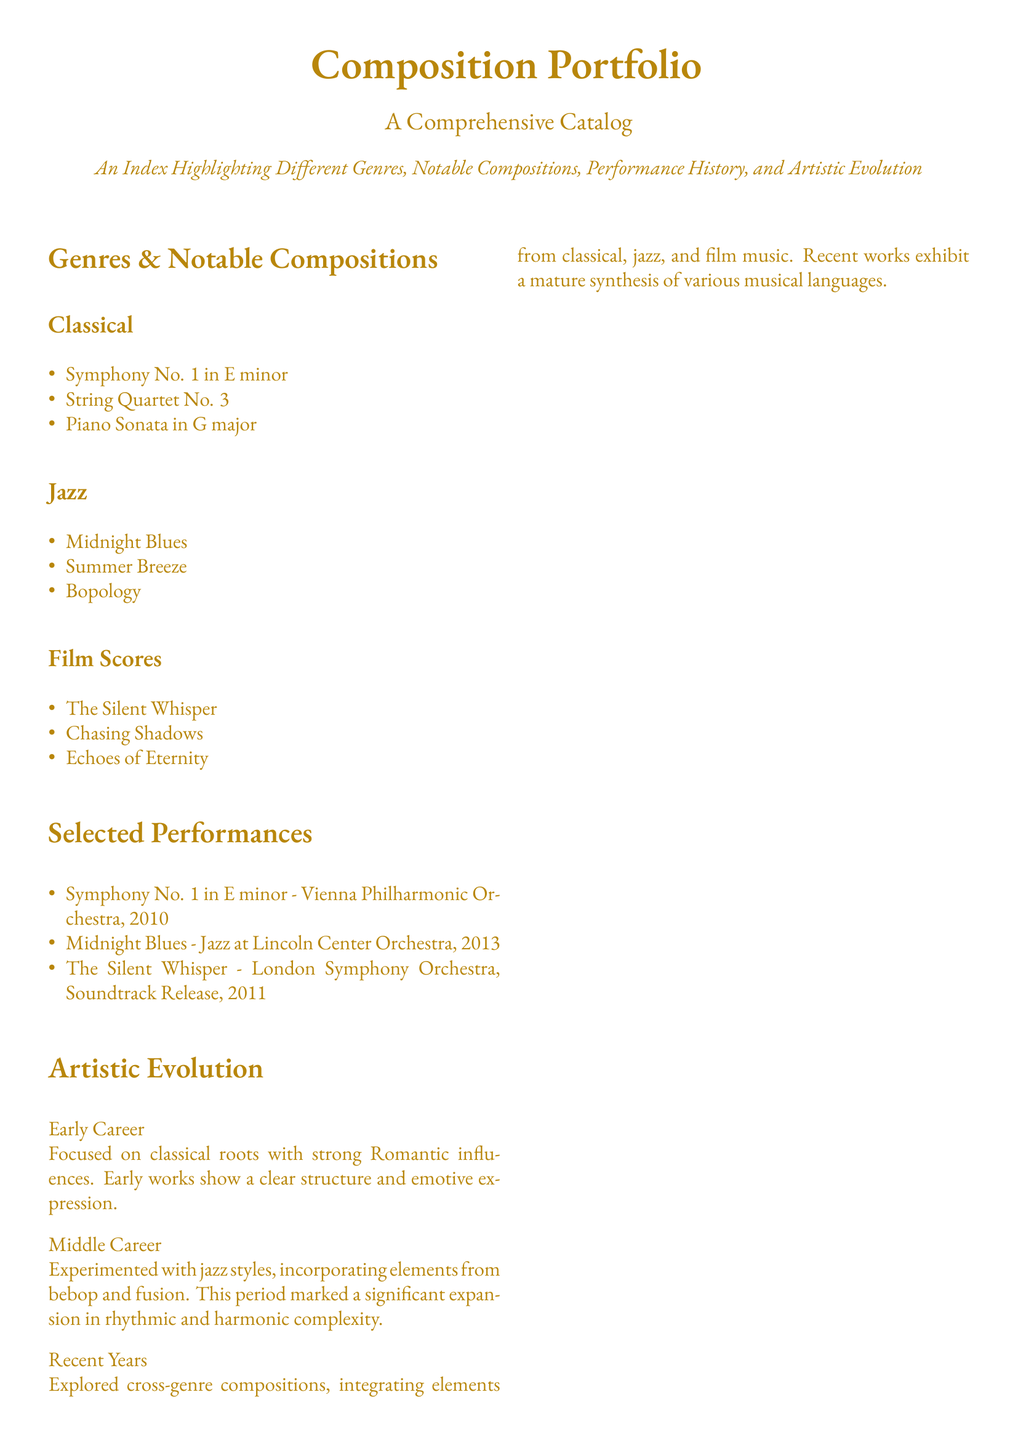What is the title of the first symphony? The first symphony listed in the document is the Symphony No. 1 in E minor.
Answer: Symphony No. 1 in E minor Which ensemble performed "Midnight Blues"? The document lists the Jazz at Lincoln Center Orchestra as the ensemble that performed "Midnight Blues."
Answer: Jazz at Lincoln Center Orchestra What year was "The Silent Whisper" performed? "The Silent Whisper" was performed in the year 2011 according to the document.
Answer: 2011 What genre is "Bopology"? "Bopology" is categorized under the Jazz genre in the document.
Answer: Jazz How many performances of classical compositions are listed? There are three performances of classical compositions indicated in the document.
Answer: 3 What does the artistic evolution of the early career focus on? The early career focuses on classical roots with strong Romantic influences.
Answer: Classical roots In which year did "Echoes of Eternity" get performed live? "Echoes of Eternity" was performed live in the year 2018 according to the document.
Answer: 2018 What type of compositions are included in the portfolio? The portfolio includes classical, jazz, and film scores compositions.
Answer: Classical, Jazz, Film Scores What does the document describe as a characteristic of recent years in artistic evolution? Recent years are characterized by exploring cross-genre compositions.
Answer: Cross-genre compositions 